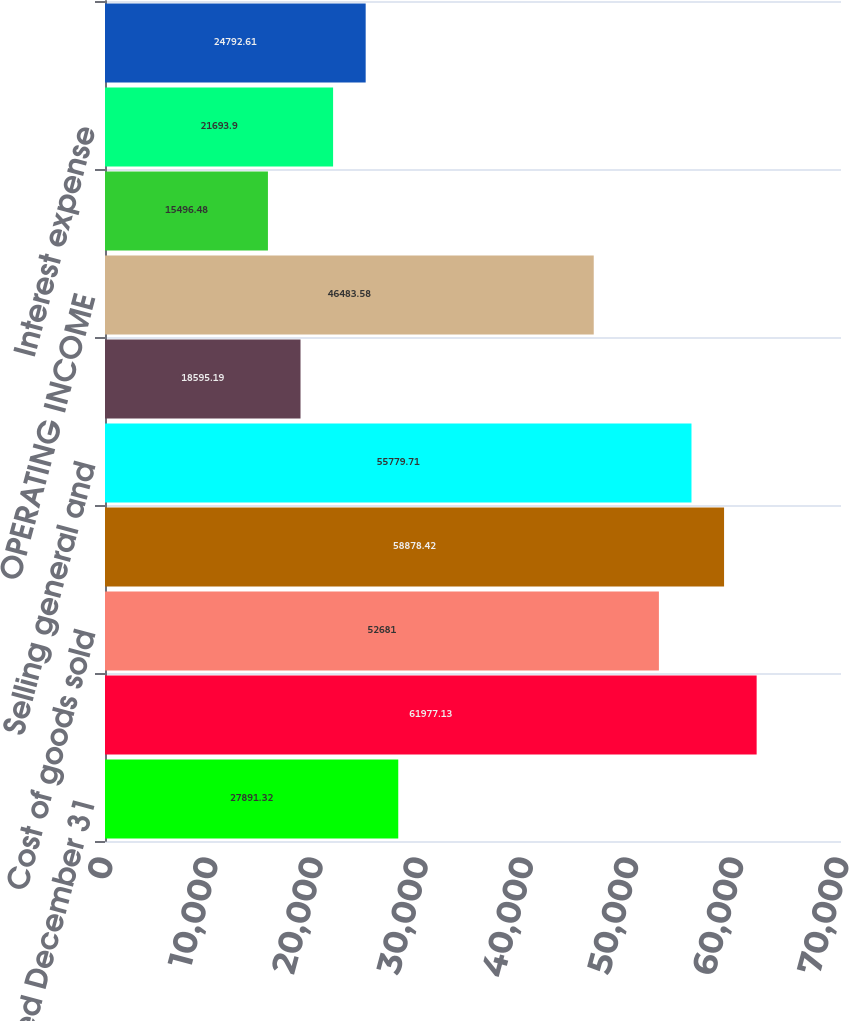Convert chart to OTSL. <chart><loc_0><loc_0><loc_500><loc_500><bar_chart><fcel>Year Ended December 31<fcel>NET OPERATING REVENUES<fcel>Cost of goods sold<fcel>GROSS PROFIT<fcel>Selling general and<fcel>Other operating charges<fcel>OPERATING INCOME<fcel>Interest income<fcel>Interest expense<fcel>Equity income (loss) - net<nl><fcel>27891.3<fcel>61977.1<fcel>52681<fcel>58878.4<fcel>55779.7<fcel>18595.2<fcel>46483.6<fcel>15496.5<fcel>21693.9<fcel>24792.6<nl></chart> 